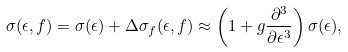<formula> <loc_0><loc_0><loc_500><loc_500>\sigma ( \epsilon , f ) = \sigma ( \epsilon ) + \Delta \sigma _ { f } ( \epsilon , f ) \approx \left ( 1 + g \frac { \partial ^ { 3 } } { \partial \epsilon ^ { 3 } } \right ) \sigma ( \epsilon ) ,</formula> 